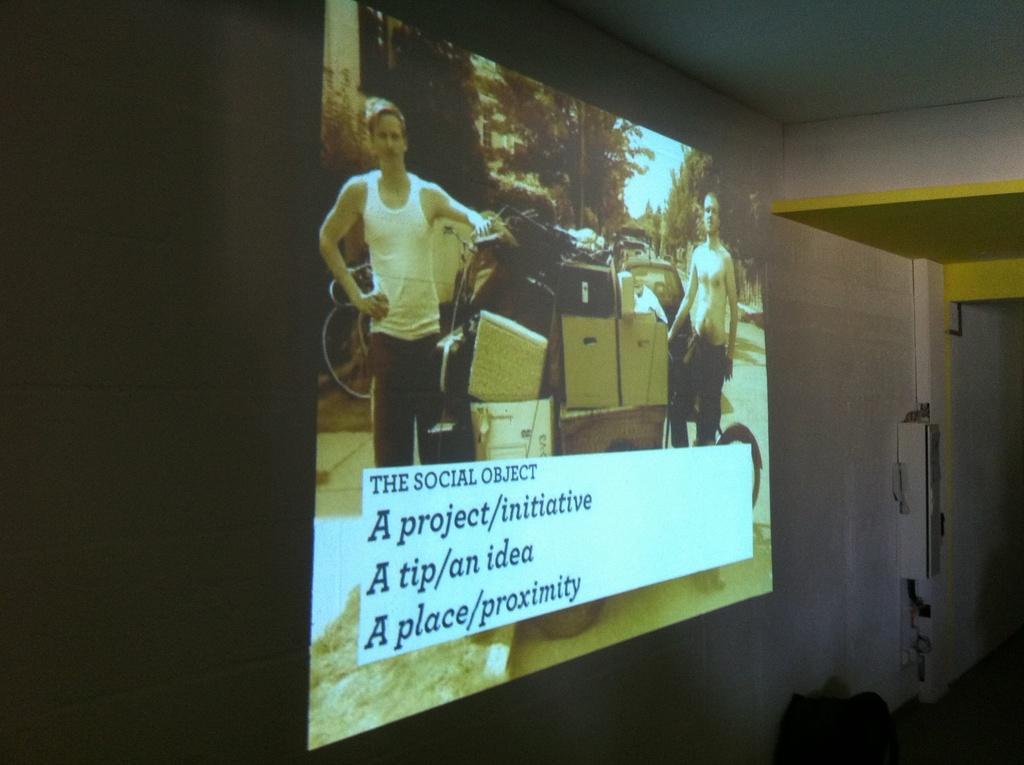Can you describe this image briefly? In this picture I can see a projector screen. On the screen I can see two men are standing and here I can see some boxes. I can also see trees and the sky. Here I can see some names. On the right side I can see a white color wall and some other objects on the floor. 